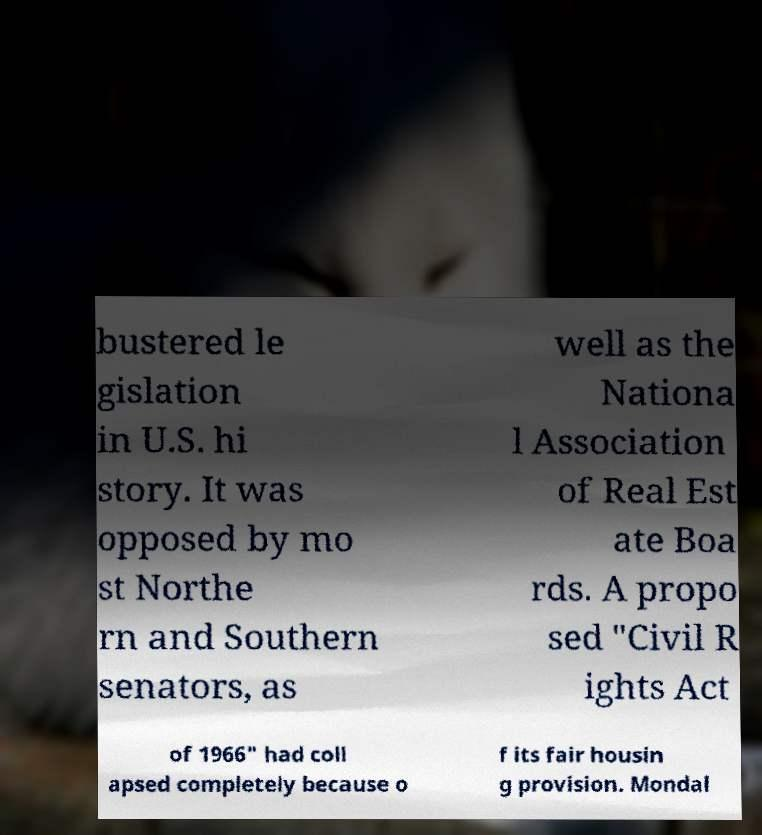Can you read and provide the text displayed in the image?This photo seems to have some interesting text. Can you extract and type it out for me? bustered le gislation in U.S. hi story. It was opposed by mo st Northe rn and Southern senators, as well as the Nationa l Association of Real Est ate Boa rds. A propo sed "Civil R ights Act of 1966" had coll apsed completely because o f its fair housin g provision. Mondal 